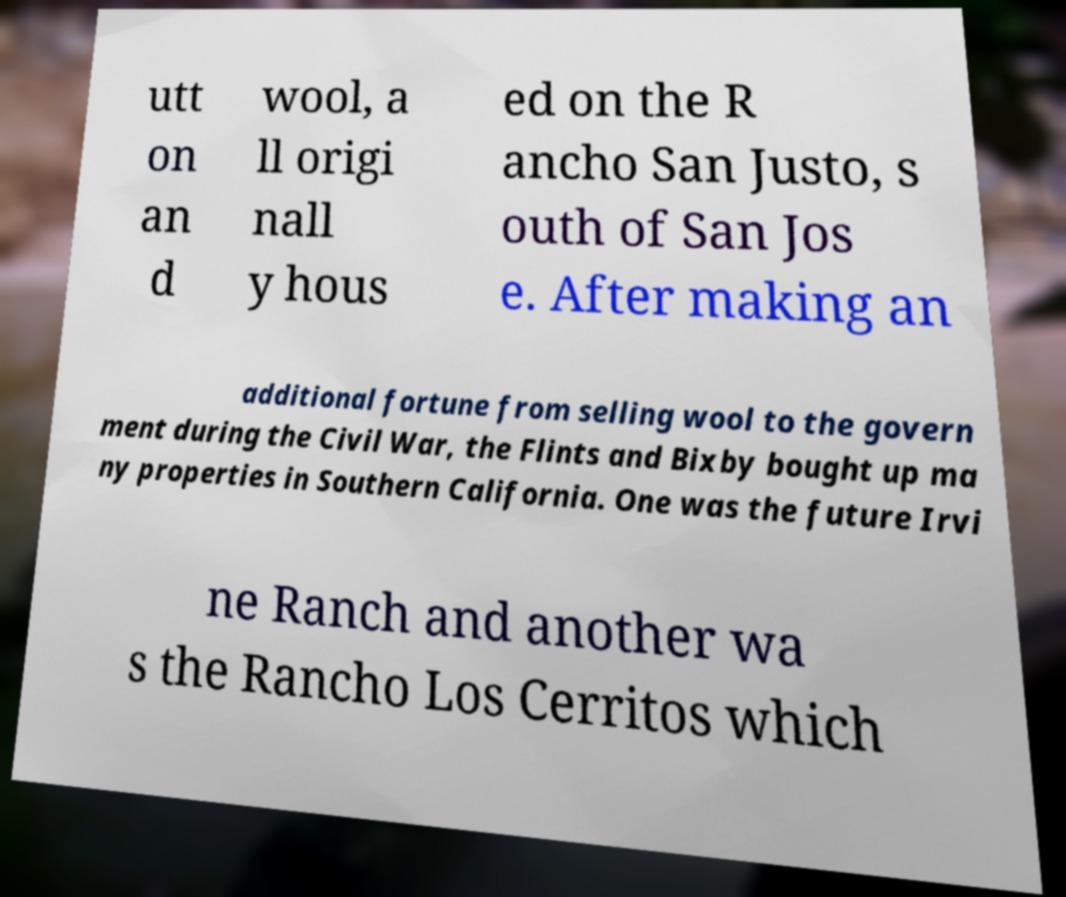For documentation purposes, I need the text within this image transcribed. Could you provide that? utt on an d wool, a ll origi nall y hous ed on the R ancho San Justo, s outh of San Jos e. After making an additional fortune from selling wool to the govern ment during the Civil War, the Flints and Bixby bought up ma ny properties in Southern California. One was the future Irvi ne Ranch and another wa s the Rancho Los Cerritos which 